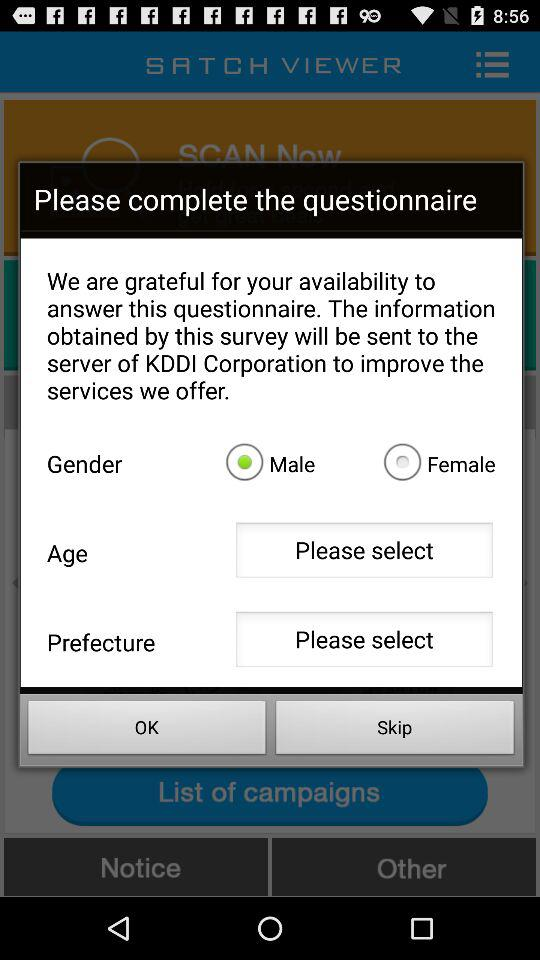What is the name of the application? The name of the application is "SATCH VIEWER". 